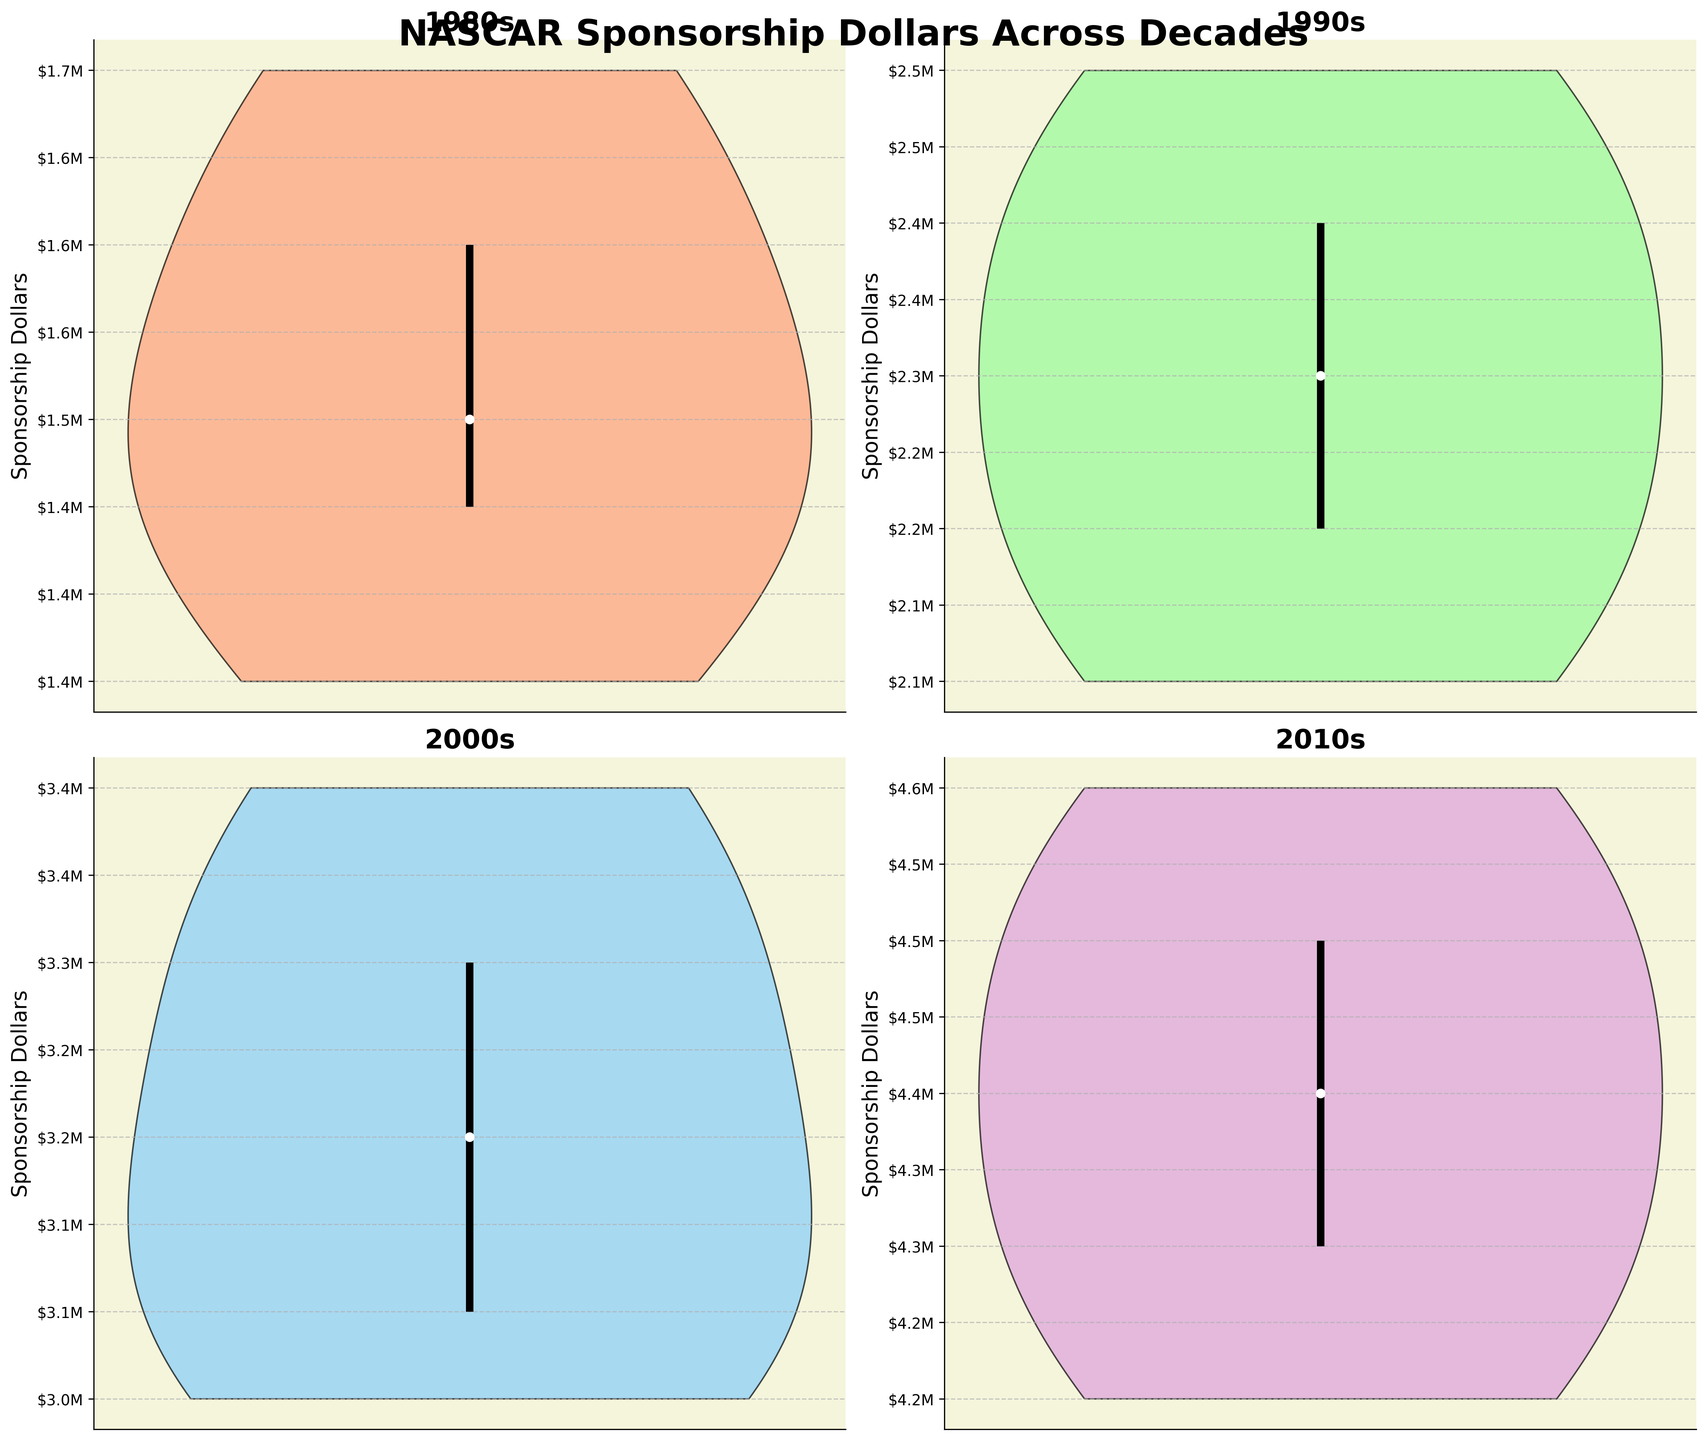Which decade has the highest median sponsorship dollars? Observing the median markers (white dots) for each decade, it's evident that the 2010s has the highest median sponsorship dollars.
Answer: 2010s How does the range of sponsorship dollars in the 1990s compare to the range in the 1980s? The range is from the first to the third quartile (vertical lines). The 1990s range is larger, indicating a more significant variability in sponsorship dollars compared to the 1980s.
Answer: 1990s range is larger Which decade shows the smallest variability in sponsorship dollars? By examining the length of the vertical lines in each violin plot, the 1980s has the shortest range, indicating the least variability.
Answer: 1980s What is the general trend in sponsorship dollars from the 1980s to the 2010s? There is an increasing trend in sponsorship dollars, with each subsequent decade showing higher values, as seen from the upward shift in the median markers.
Answer: Increasing Which decades have a median sponsorship value below $2 million? The median (white dot) for the 1980s and 1990s both fall below the $2 million mark on their respective y-axes.
Answer: 1980s, 1990s What can be said about quartile distributions in the 2000s? The vertical line within the 2000s violin plot shows the spacing between the first, second (median), and third quartiles, which indicates a moderate spread of data.
Answer: Moderate spread Which decade has the widest interquartile range (IQR)? By measuring the distance between the first and third quartile markers (top and bottom of the vertical line), the 2010s show the widest IQR.
Answer: 2010s Comparing the 1980s and the 2000s, which decade has a higher upper quartile (Q3) value? The top of the vertical line for the 2000s is higher on the y-axis compared to the 1980s, indicating a higher Q3 value.
Answer: 2000s Is the sponsorship dollar distribution for the 2010s skewed? If yes, in which direction? The upper part of the 2010s violin plot appears larger, suggesting a positive skew.
Answer: Positive skew 